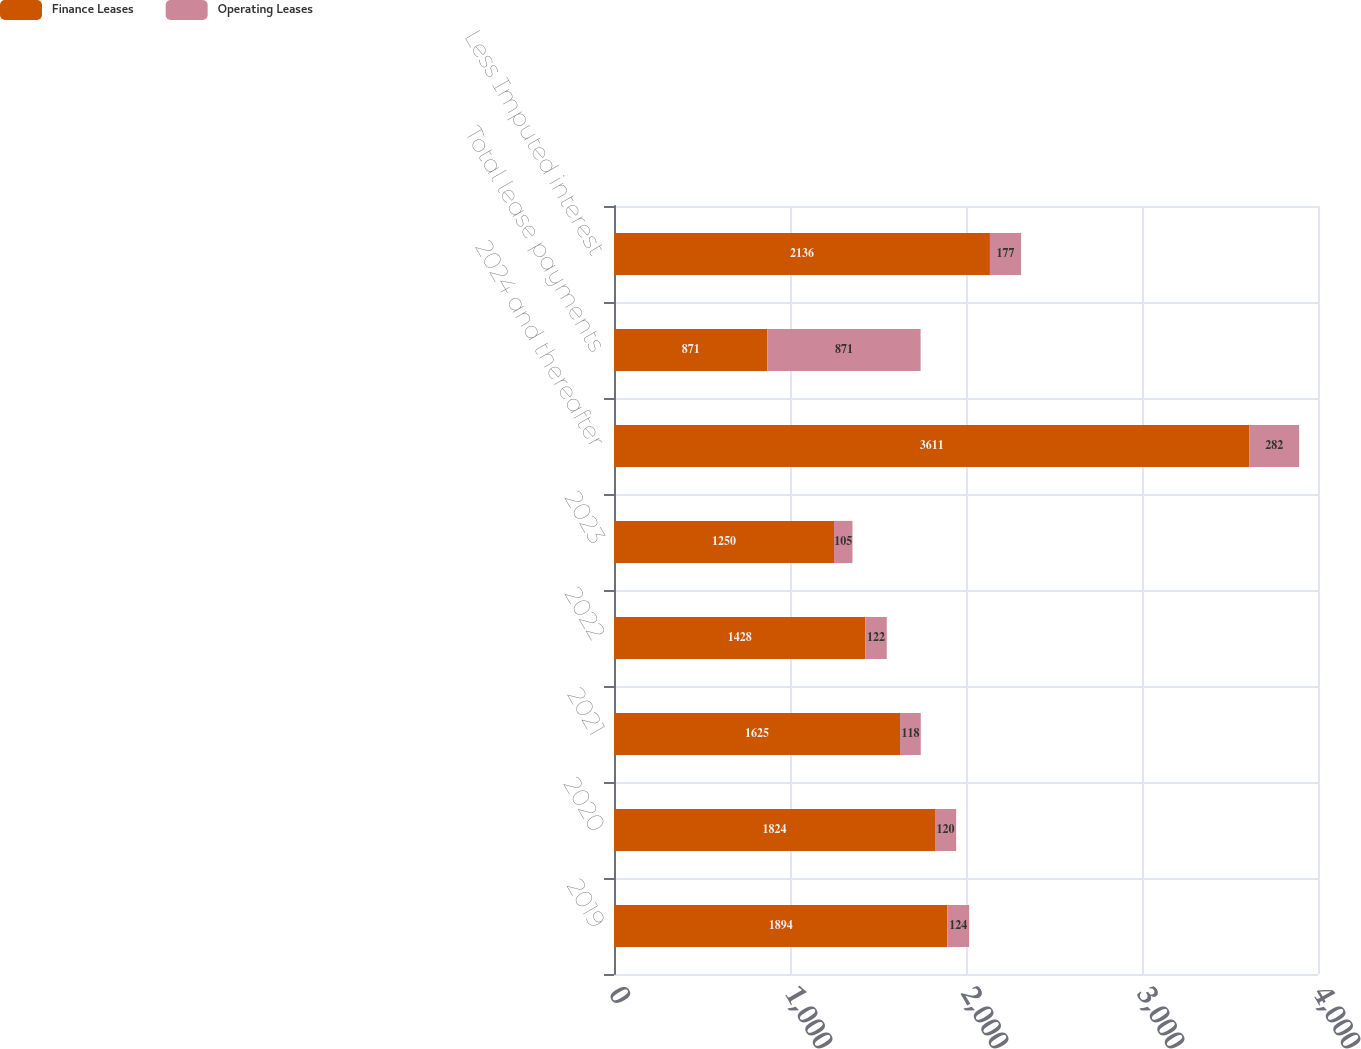<chart> <loc_0><loc_0><loc_500><loc_500><stacked_bar_chart><ecel><fcel>2019<fcel>2020<fcel>2021<fcel>2022<fcel>2023<fcel>2024 and thereafter<fcel>Total lease payments<fcel>Less Imputed interest<nl><fcel>Finance Leases<fcel>1894<fcel>1824<fcel>1625<fcel>1428<fcel>1250<fcel>3611<fcel>871<fcel>2136<nl><fcel>Operating Leases<fcel>124<fcel>120<fcel>118<fcel>122<fcel>105<fcel>282<fcel>871<fcel>177<nl></chart> 